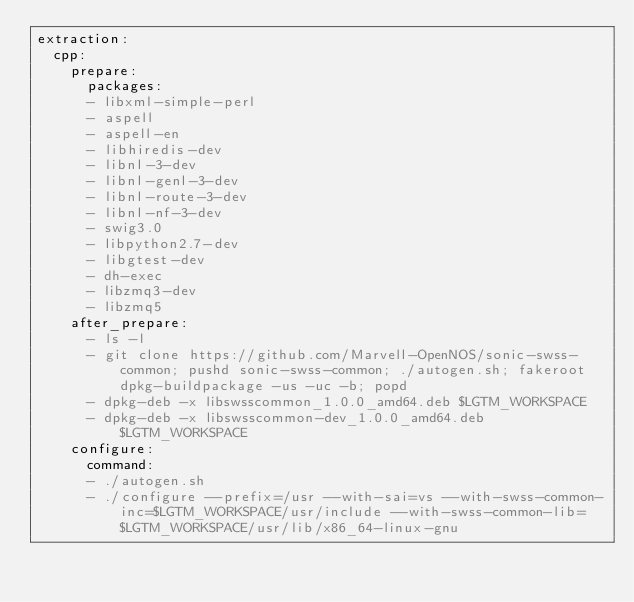Convert code to text. <code><loc_0><loc_0><loc_500><loc_500><_YAML_>extraction:
  cpp:
    prepare:
      packages:
      - libxml-simple-perl
      - aspell
      - aspell-en
      - libhiredis-dev
      - libnl-3-dev
      - libnl-genl-3-dev
      - libnl-route-3-dev
      - libnl-nf-3-dev
      - swig3.0
      - libpython2.7-dev
      - libgtest-dev
      - dh-exec
      - libzmq3-dev
      - libzmq5
    after_prepare:
      - ls -l
      - git clone https://github.com/Marvell-OpenNOS/sonic-swss-common; pushd sonic-swss-common; ./autogen.sh; fakeroot dpkg-buildpackage -us -uc -b; popd
      - dpkg-deb -x libswsscommon_1.0.0_amd64.deb $LGTM_WORKSPACE
      - dpkg-deb -x libswsscommon-dev_1.0.0_amd64.deb $LGTM_WORKSPACE
    configure:
      command:
      - ./autogen.sh
      - ./configure --prefix=/usr --with-sai=vs --with-swss-common-inc=$LGTM_WORKSPACE/usr/include --with-swss-common-lib=$LGTM_WORKSPACE/usr/lib/x86_64-linux-gnu
</code> 